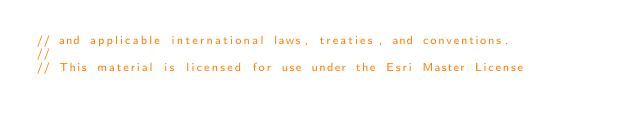Convert code to text. <code><loc_0><loc_0><loc_500><loc_500><_JavaScript_>// and applicable international laws, treaties, and conventions.
//
// This material is licensed for use under the Esri Master License</code> 